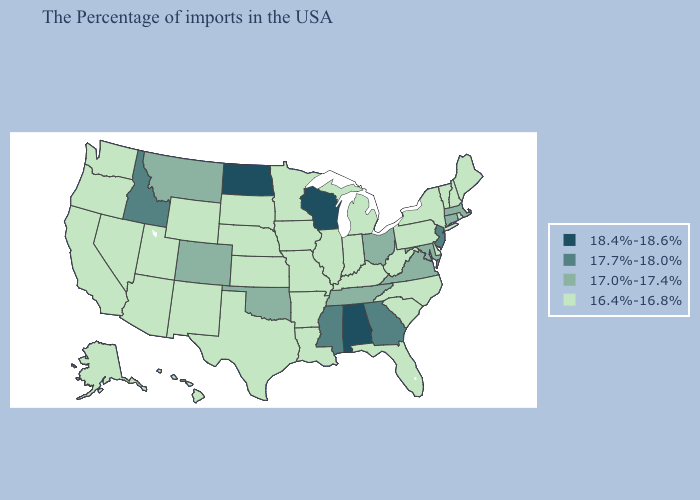Name the states that have a value in the range 17.7%-18.0%?
Answer briefly. New Jersey, Georgia, Mississippi, Idaho. Does Louisiana have the highest value in the South?
Short answer required. No. Does New Jersey have a higher value than Idaho?
Give a very brief answer. No. Does Arizona have the lowest value in the West?
Keep it brief. Yes. What is the lowest value in the USA?
Answer briefly. 16.4%-16.8%. What is the highest value in the USA?
Short answer required. 18.4%-18.6%. Does Vermont have the highest value in the Northeast?
Write a very short answer. No. Name the states that have a value in the range 17.7%-18.0%?
Keep it brief. New Jersey, Georgia, Mississippi, Idaho. Which states have the lowest value in the West?
Keep it brief. Wyoming, New Mexico, Utah, Arizona, Nevada, California, Washington, Oregon, Alaska, Hawaii. Is the legend a continuous bar?
Answer briefly. No. What is the value of Minnesota?
Be succinct. 16.4%-16.8%. What is the value of Kansas?
Answer briefly. 16.4%-16.8%. Does Nevada have the same value as North Carolina?
Keep it brief. Yes. Does the first symbol in the legend represent the smallest category?
Quick response, please. No. 